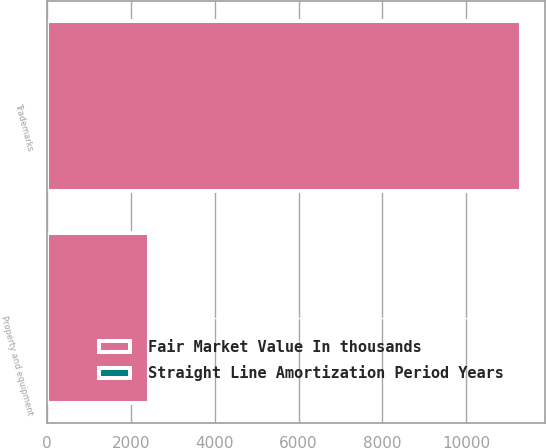<chart> <loc_0><loc_0><loc_500><loc_500><stacked_bar_chart><ecel><fcel>Property and equipment<fcel>Trademarks<nl><fcel>Fair Market Value In thousands<fcel>2433<fcel>11310<nl><fcel>Straight Line Amortization Period Years<fcel>12<fcel>5<nl></chart> 